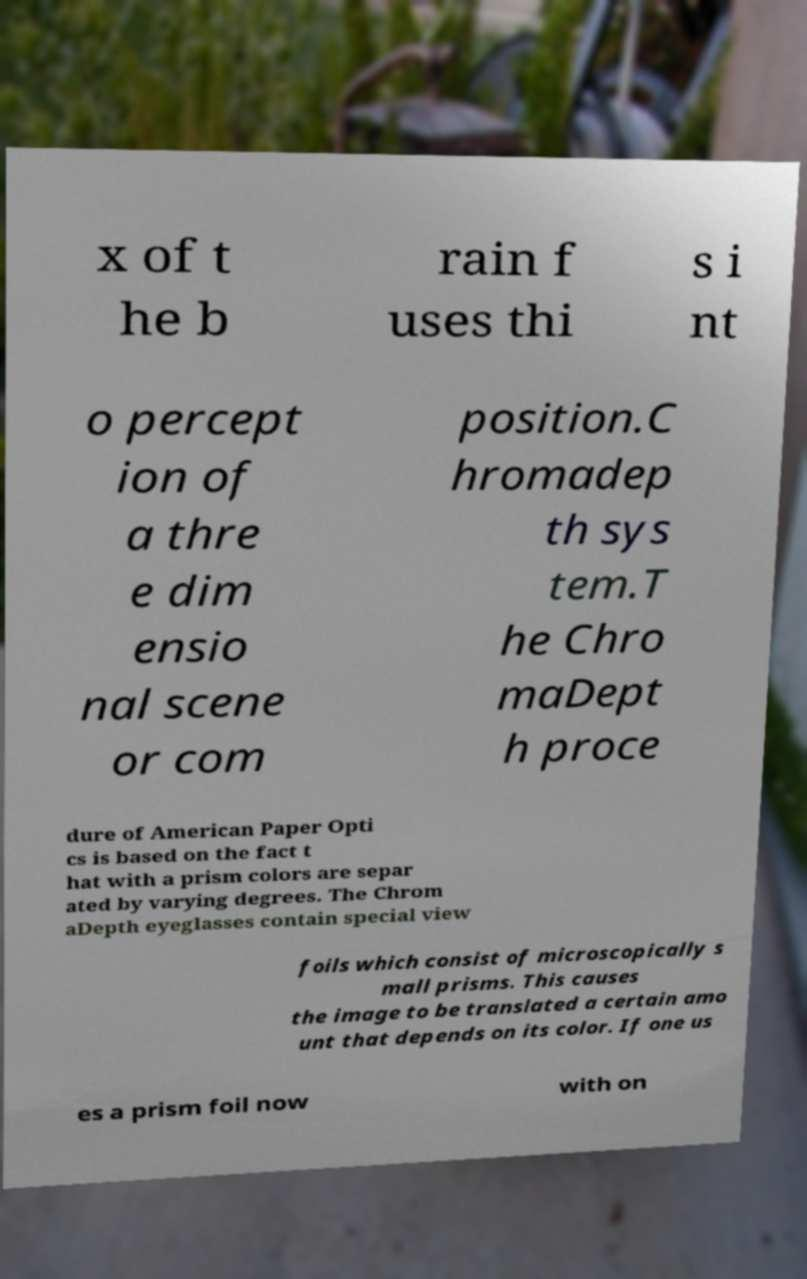Could you extract and type out the text from this image? x of t he b rain f uses thi s i nt o percept ion of a thre e dim ensio nal scene or com position.C hromadep th sys tem.T he Chro maDept h proce dure of American Paper Opti cs is based on the fact t hat with a prism colors are separ ated by varying degrees. The Chrom aDepth eyeglasses contain special view foils which consist of microscopically s mall prisms. This causes the image to be translated a certain amo unt that depends on its color. If one us es a prism foil now with on 